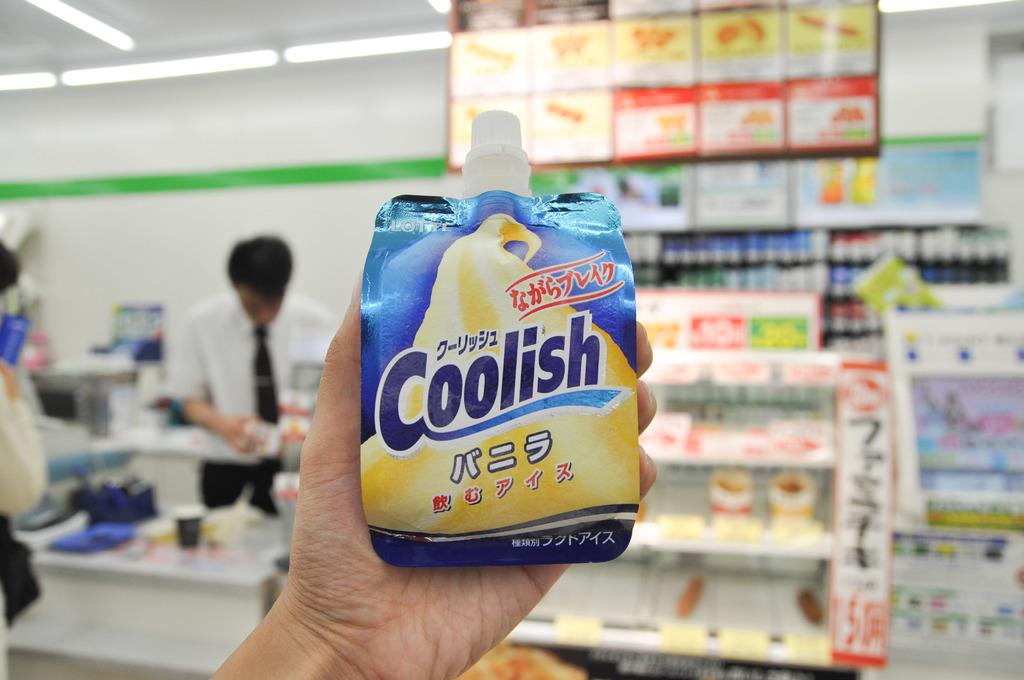What's the name of the product?
Offer a very short reply. Coolish. What is the name of the item being held up?
Give a very brief answer. Coolish. 